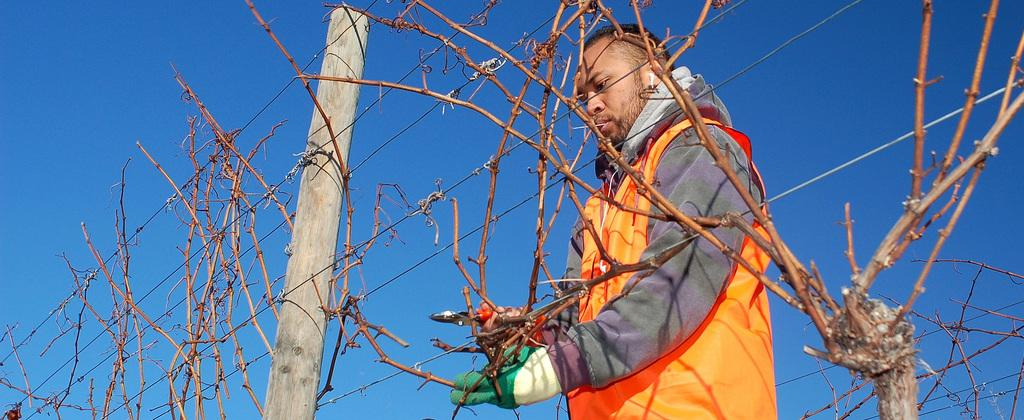Who is the main subject in the image? There is a man in the middle of the image. What is the man doing in the image? The man is making a fence. What is the man wearing in the image? The man is wearing a coat. What is visible at the top of the image? The sky is visible at the top of the image. How many fingers does the man have on his fifth hand in the image? The man does not have a fifth hand in the image, and therefore the number of fingers on it cannot be determined. 